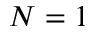Convert formula to latex. <formula><loc_0><loc_0><loc_500><loc_500>N = 1</formula> 